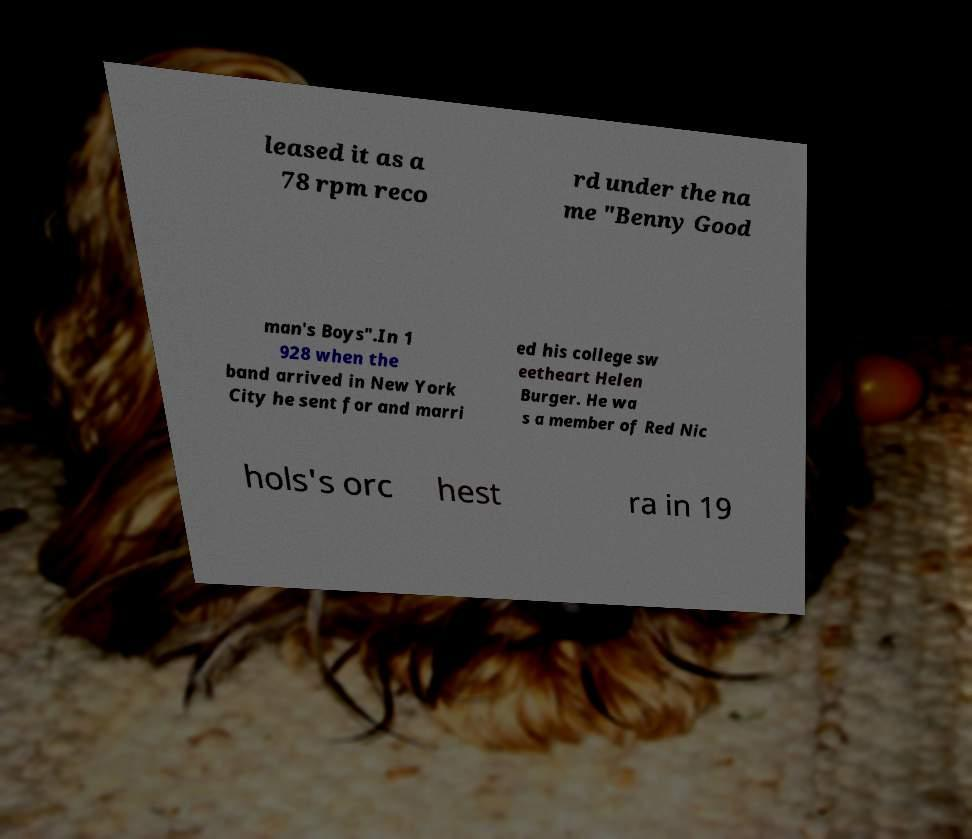Can you read and provide the text displayed in the image?This photo seems to have some interesting text. Can you extract and type it out for me? leased it as a 78 rpm reco rd under the na me "Benny Good man's Boys".In 1 928 when the band arrived in New York City he sent for and marri ed his college sw eetheart Helen Burger. He wa s a member of Red Nic hols's orc hest ra in 19 